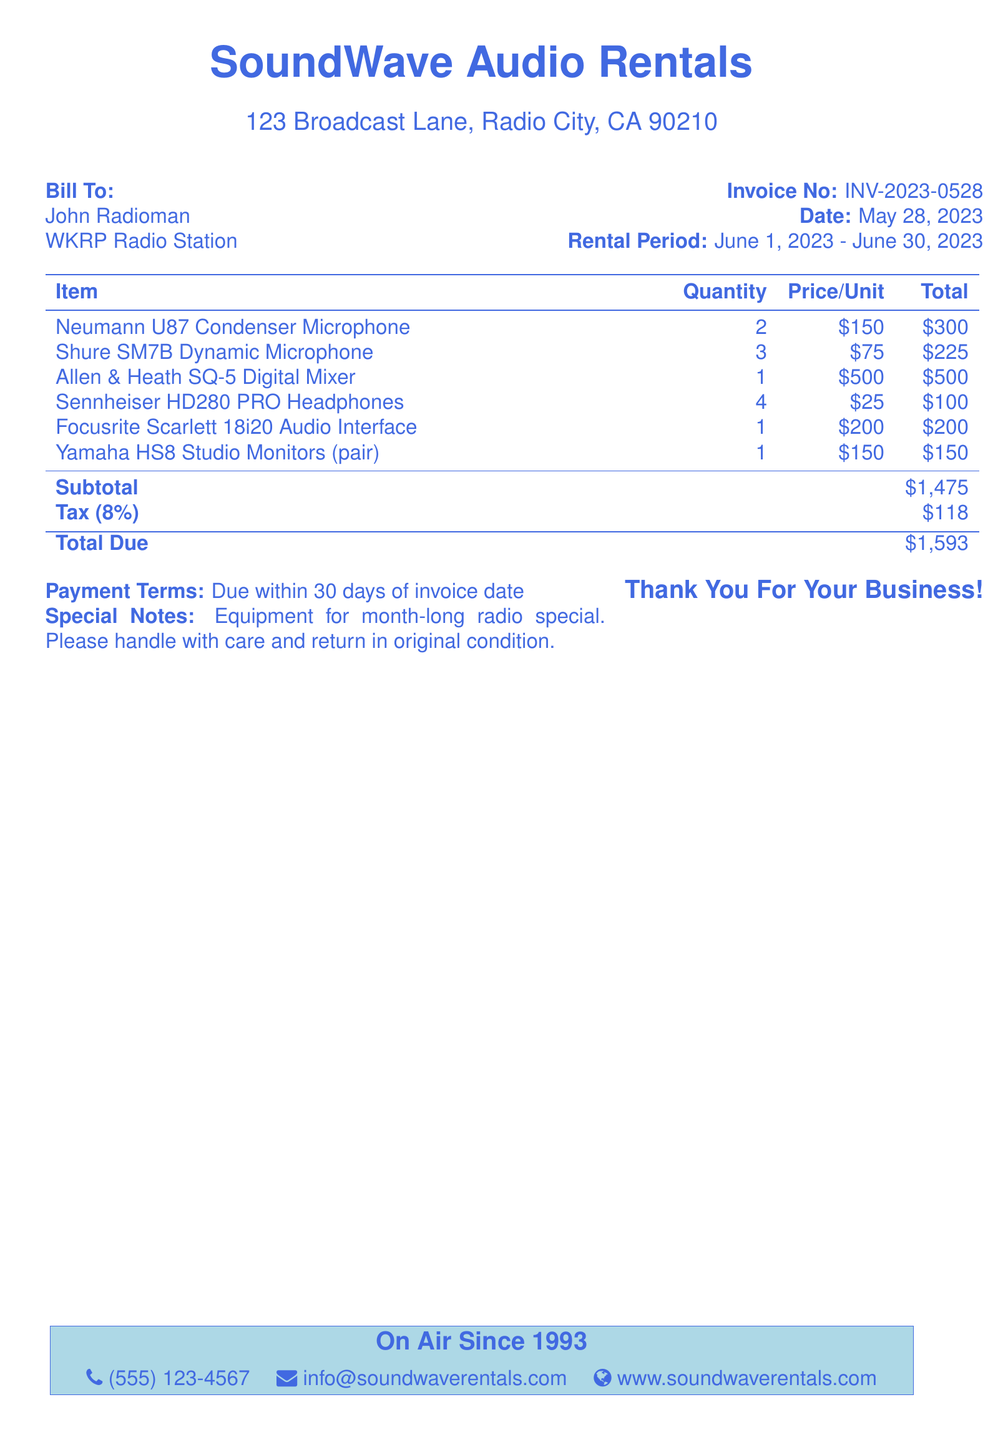What is the name of the company issuing the invoice? The name of the company is prominently displayed at the top of the document.
Answer: SoundWave Audio Rentals Who is the bill addressed to? The document specifies the recipient's name under "Bill To" section.
Answer: John Radioman What is the total amount due? The document summarizes the financial details at the end, indicating the total due.
Answer: $1,593 What is the rental period specified in the invoice? The duration for which the equipment is rented is stated in the "Rental Period" section.
Answer: June 1, 2023 - June 30, 2023 How many Neumann U87 Condenser Microphones were rented? The quantity of this specific item is listed in the itemized table.
Answer: 2 What is the subtotal amount before tax? The subtotal is clearly indicated in the breakdown of charges in the document.
Answer: $1,475 What percentage is the tax applied to the rental? The tax rate is specified in the financial section of the document.
Answer: 8% What are the payment terms stated in the invoice? Payment conditions are mentioned towards the bottom of the document.
Answer: Due within 30 days of invoice date What special notes are included in the invoice? Specific instructions or comments regarding the rental are noted in the document.
Answer: Equipment for month-long radio special. Please handle with care and return in original condition 